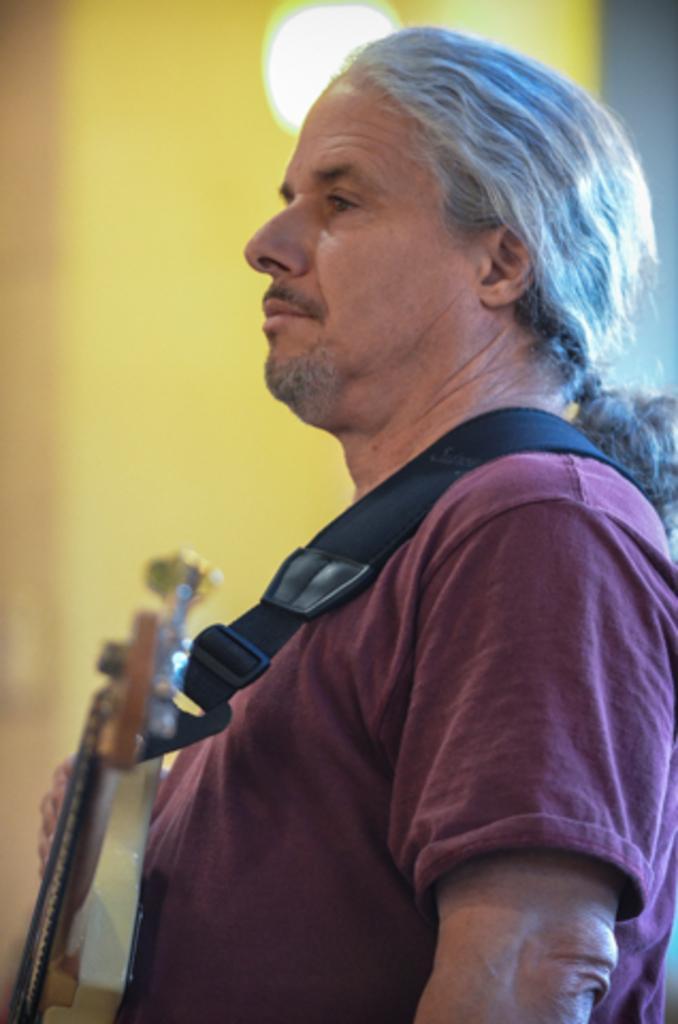How would you summarize this image in a sentence or two? This man wore t-shirt and guitar. On top there is a light. 